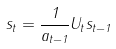<formula> <loc_0><loc_0><loc_500><loc_500>s _ { t } = \frac { 1 } { a _ { t - 1 } } U _ { t } s _ { t - 1 }</formula> 